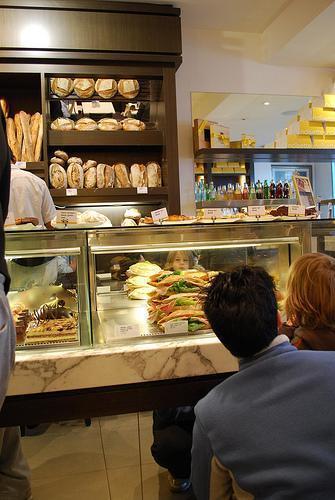How many people are looking at the display case?
Give a very brief answer. 2. 